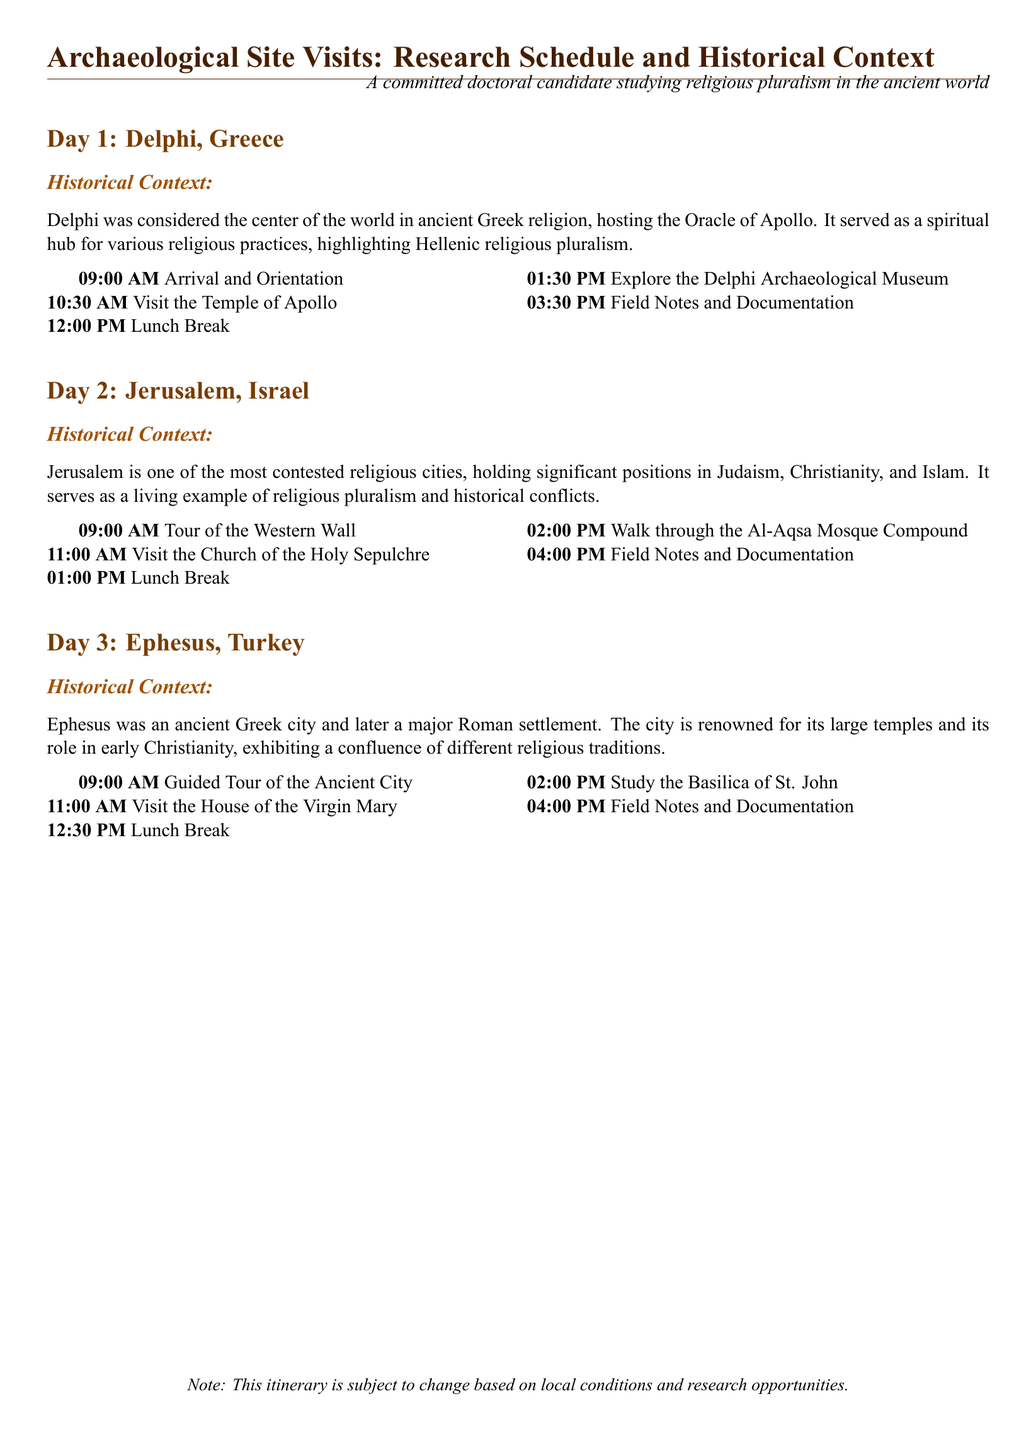What is the first site visited on Day 1? The first site visited on Day 1 is the Temple of Apollo in Delphi.
Answer: Temple of Apollo What time does the visit to the Church of the Holy Sepulchre start? The visit to the Church of the Holy Sepulchre starts at 11:00 AM.
Answer: 11:00 AM Which city's visit highlights significant positions in Judaism, Christianity, and Islam? Jerusalem highlights significant positions in Judaism, Christianity, and Islam.
Answer: Jerusalem What is the last activity scheduled for Day 3? The last activity scheduled for Day 3 is Field Notes and Documentation.
Answer: Field Notes and Documentation How many days are included in the itinerary? The itinerary includes three days of site visits.
Answer: Three days What is the lunch break duration on Day 2? The lunch break duration on Day 2 is for 1 hour.
Answer: 1 hour What historical context is provided for Ephesus? The historical context for Ephesus highlights its role in early Christianity and different religious traditions.
Answer: Role in early Christianity What time does the tour of the Western Wall start on Day 2? The tour of the Western Wall starts at 9:00 AM on Day 2.
Answer: 9:00 AM What is the name of the museum visited on Day 1? The museum visited on Day 1 is the Delphi Archaeological Museum.
Answer: Delphi Archaeological Museum 